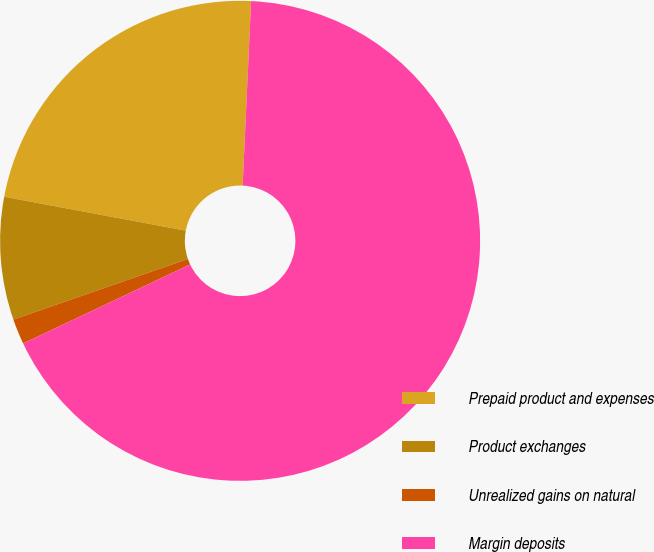Convert chart. <chart><loc_0><loc_0><loc_500><loc_500><pie_chart><fcel>Prepaid product and expenses<fcel>Product exchanges<fcel>Unrealized gains on natural<fcel>Margin deposits<nl><fcel>22.79%<fcel>8.26%<fcel>1.71%<fcel>67.24%<nl></chart> 